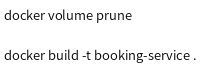<code> <loc_0><loc_0><loc_500><loc_500><_Bash_>docker volume prune

docker build -t booking-service .
</code> 